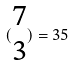<formula> <loc_0><loc_0><loc_500><loc_500>( \begin{matrix} 7 \\ 3 \end{matrix} ) = 3 5</formula> 